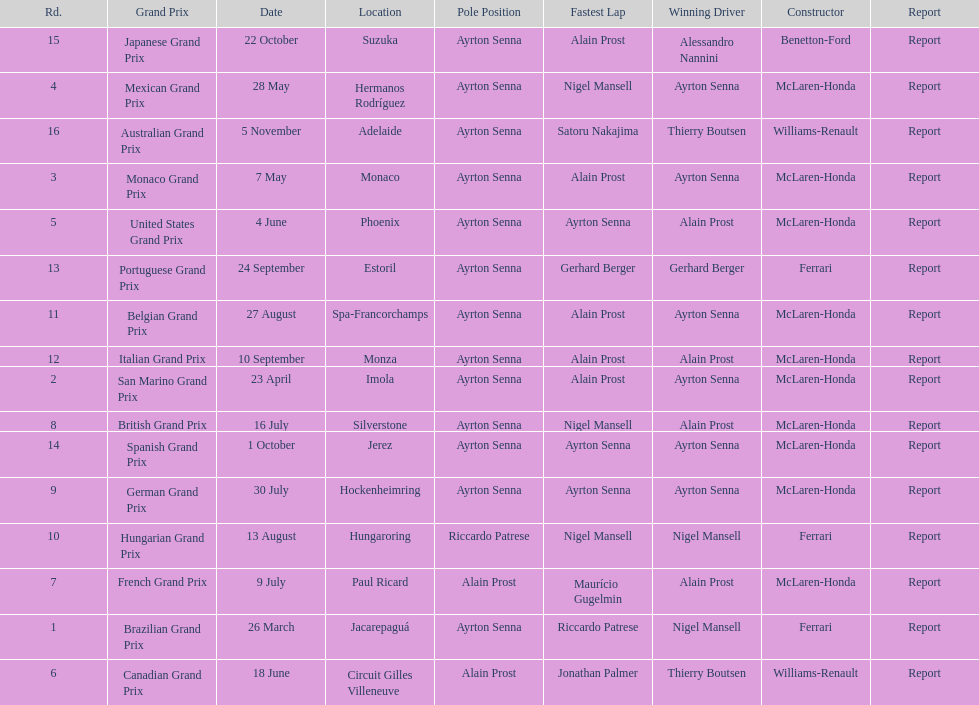What was the only grand prix to be won by benneton-ford? Japanese Grand Prix. 